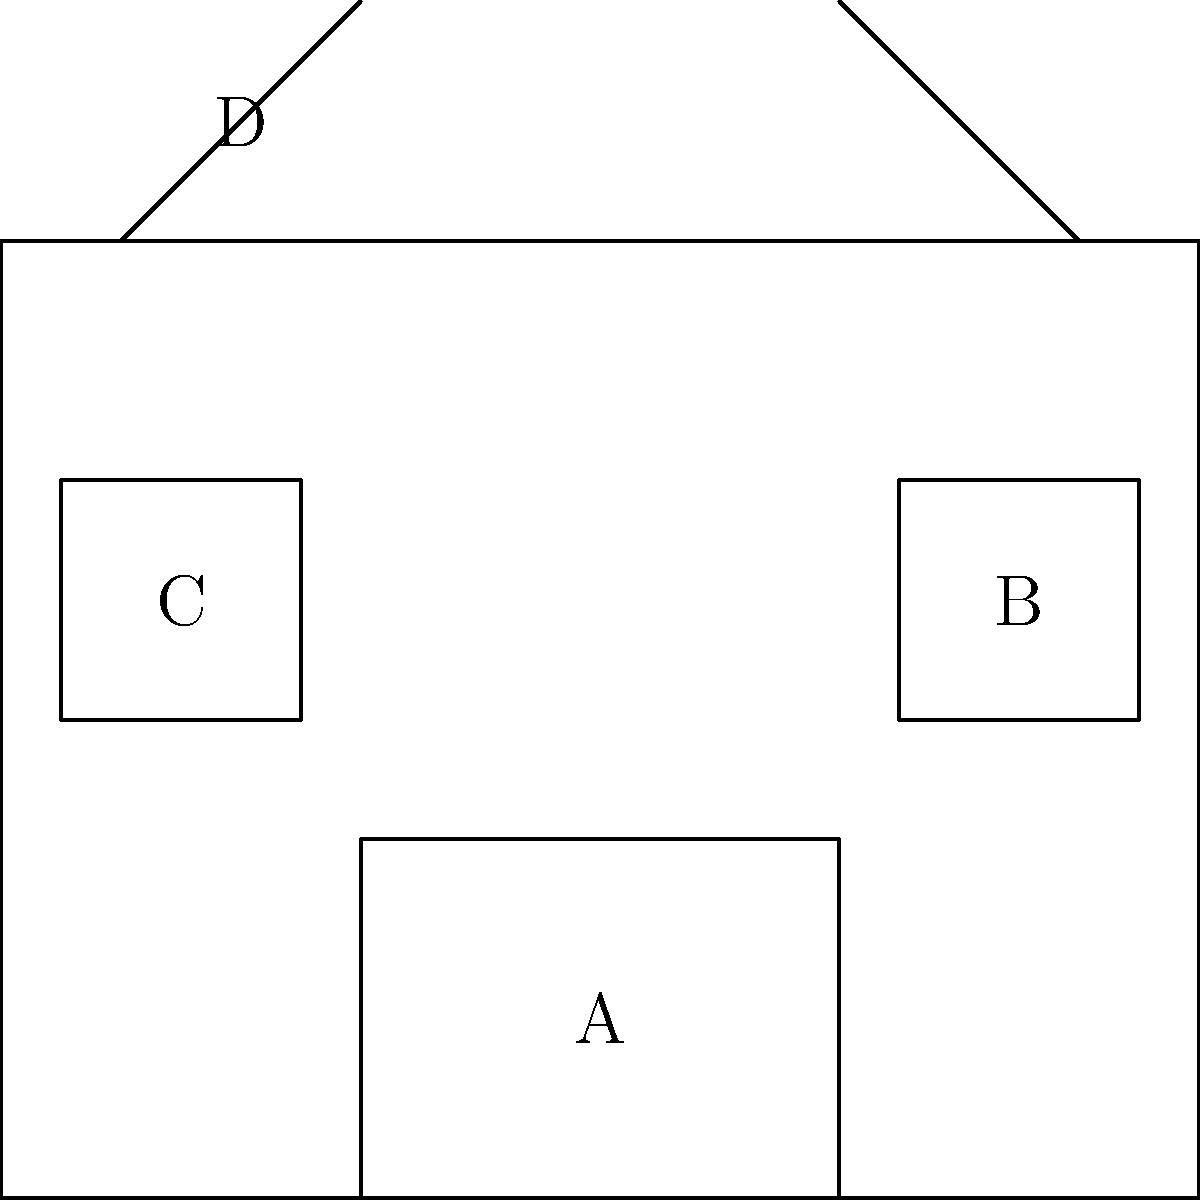In the diagram of a cutting-edge drone weapon system, which component labeled A, B, C, or D represents the most critical element for maximizing the drone's operational range and mission duration? To determine the most critical element for maximizing the drone's operational range and mission duration, let's analyze each labeled component:

1. Component A: This appears to be the payload bay, which houses the weapon system or surveillance equipment. While important for the mission, it doesn't directly affect range or duration.

2. Component B: This represents the control system, which is crucial for navigation and operation but doesn't significantly impact range or duration.

3. Component C: This is the battery, which is the power source for the entire system. The battery's capacity directly determines how long the drone can operate and how far it can travel.

4. Component D: These are the propellers, which provide thrust for the drone. While efficient propellers can improve range, they are not as critical as the power source.

The battery (C) is the most critical element for maximizing operational range and mission duration because:

1. It supplies power to all systems, including propulsion, control, and payload.
2. The battery's capacity directly correlates with how long the drone can stay airborne.
3. Advancements in battery technology (e.g., higher energy density) can significantly improve a drone's performance without changing other components.
4. Modern lithium-polymer batteries used in drones offer high energy density and low weight, making them ideal for maximizing range and duration.
Answer: C (Battery) 